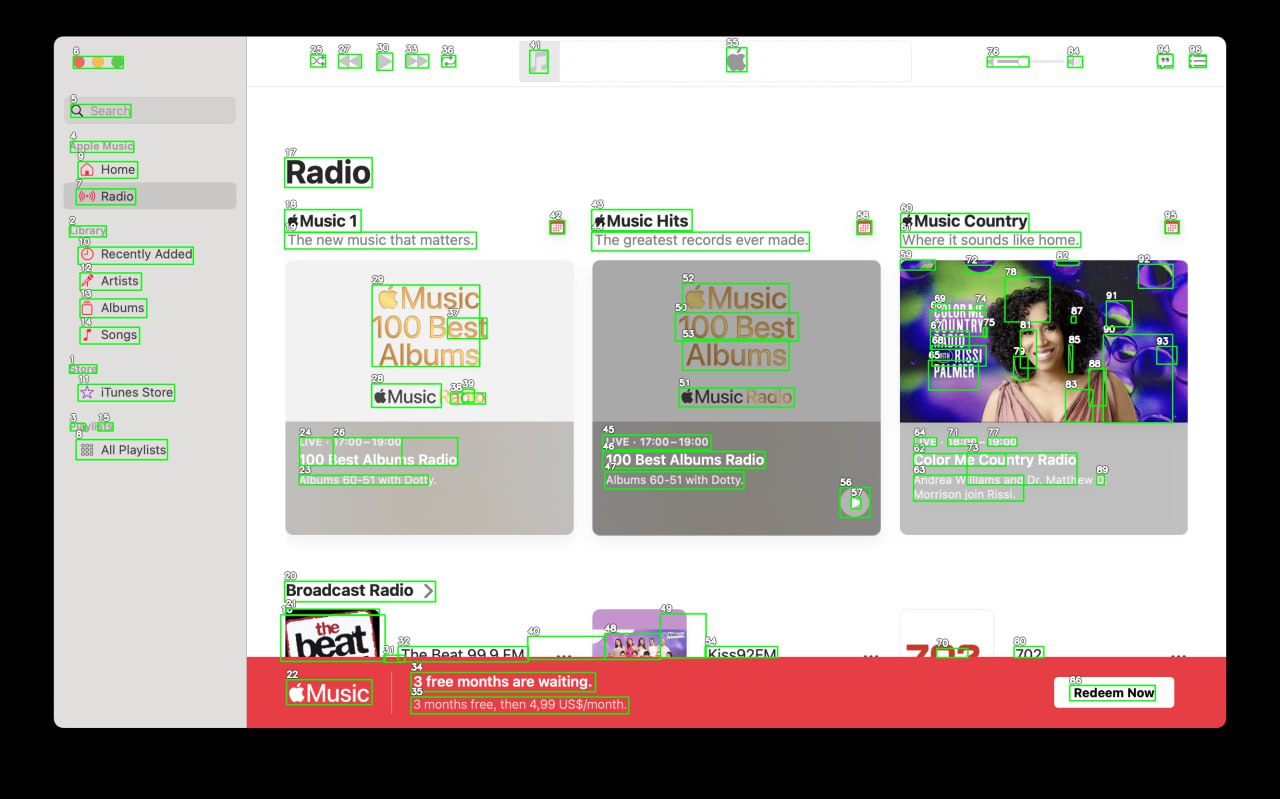Your task is to analyze the screenshot of the {app_name} on MacOS.  The screenshot is segmented with bounding boxes, each labeled with a number. The labels are always white numbers with a black outline. Number is always situated in the top left corner above the box. Segment the screen into logical parts, for example: top bar, main menu, ads bar etc. Provide as many categories as you can. Provide the output in JSON format connecting every category with list of numbers of the boxes that lie inside it.

For example,{
  "top_bar": [4, 7, 9, 13],
  "main_menu": [3, 8, 10, 15],
  "main_content": [6, 11, 12, 14, 16, 17],
  "ads_bar": [1, 2, 5]
}Note that you must find as many categories as you can, and can add subcategories inside of each of the categories.
 ```json
{
  "top_bar": [4, 7, 9, 13, 6],
  "main_menu": [3, 8, 10, 15, 1],
  "main_content": [
    {
      "radio_category": [17, 18, 19, 20, 21, 22, 23, 24, 25, 26, 27, 28, 29, 30, 31, 32, 33, 34, 35, 36, 37, 38, 39]
    },
    {
      "radio_category": [41, 42, 43, 44, 45, 46, 47, 48, 49, 50, 51, 52, 53, 54, 55, 56, 57]
    },
    {
      "radio_category": [58, 59, 60, 61, 62, 63, 64, 65, 66, 67, 68, 69, 70, 71, 72, 73, 74, 75, 76, 77, 78, 79, 80, 81, 82, 83, 84, 85, 86, 87, 88, 89, 90, 91, 92, 93]
    }
  ],
  "ads_bar": [22, 34, 35, 84, 94, 95, 96, 97, 98, 99, 100, 101, 102, 103, 104, 105, 106, 107, 108, 109, 110, 111, 112, 113, 114, 115, 116, 117, 118, 119, 120, 121, 122]
}
``` 